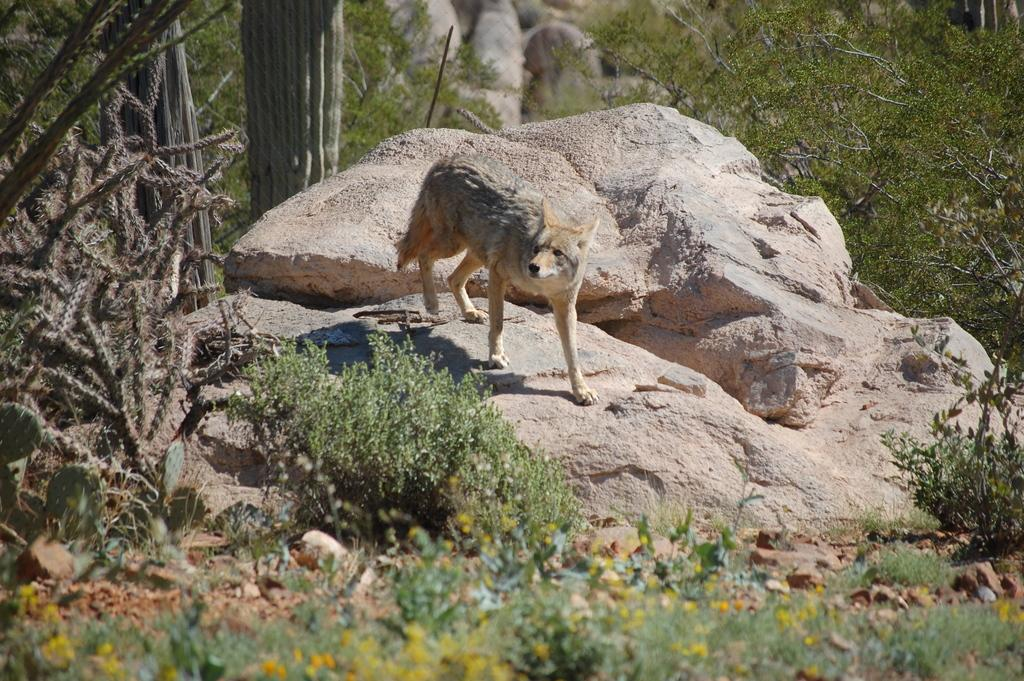What animal is present in the image? There is a jackal in the image. What is the jackal doing in the image? The jackal is walking. What can be seen at the bottom of the image? There are plants at the bottom of the image. What is located in the middle of the image? There is a rock in the middle of the image. What type of vegetation is visible in the background of the image? There are plants in the background of the image. How many stones are being kissed by the jackal in the image? There are no stones or kissing actions present in the image. 